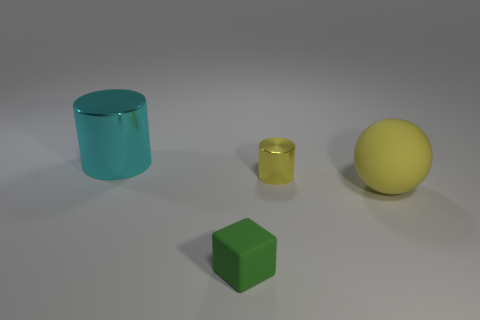Add 1 small objects. How many objects exist? 5 Subtract all blocks. How many objects are left? 3 Add 1 yellow shiny objects. How many yellow shiny objects exist? 2 Subtract 0 cyan spheres. How many objects are left? 4 Subtract all blue rubber things. Subtract all cyan cylinders. How many objects are left? 3 Add 4 yellow rubber objects. How many yellow rubber objects are left? 5 